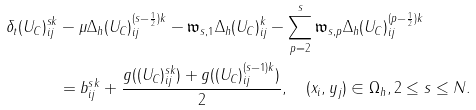Convert formula to latex. <formula><loc_0><loc_0><loc_500><loc_500>\delta _ { t } ( U _ { C } ) ^ { s k } _ { i j } & - \mu \Delta _ { h } ( U _ { C } ) ^ { ( s - \frac { 1 } { 2 } ) k } _ { i j } - \mathfrak { w } _ { s , 1 } \Delta _ { h } ( U _ { C } ) ^ { k } _ { i j } - \sum _ { p = 2 } ^ { s } \mathfrak { w } _ { s , p } \Delta _ { h } ( U _ { C } ) ^ { ( p - \frac { 1 } { 2 } ) k } _ { i j } \\ & = b ^ { s k } _ { i j } + \frac { g ( ( U _ { C } ) ^ { s k } _ { i j } ) + g ( ( U _ { C } ) ^ { ( s - 1 ) k } _ { i j } ) } { 2 } , \quad ( x _ { i } , y _ { j } ) \in \Omega _ { h } , 2 \leq s \leq N .</formula> 